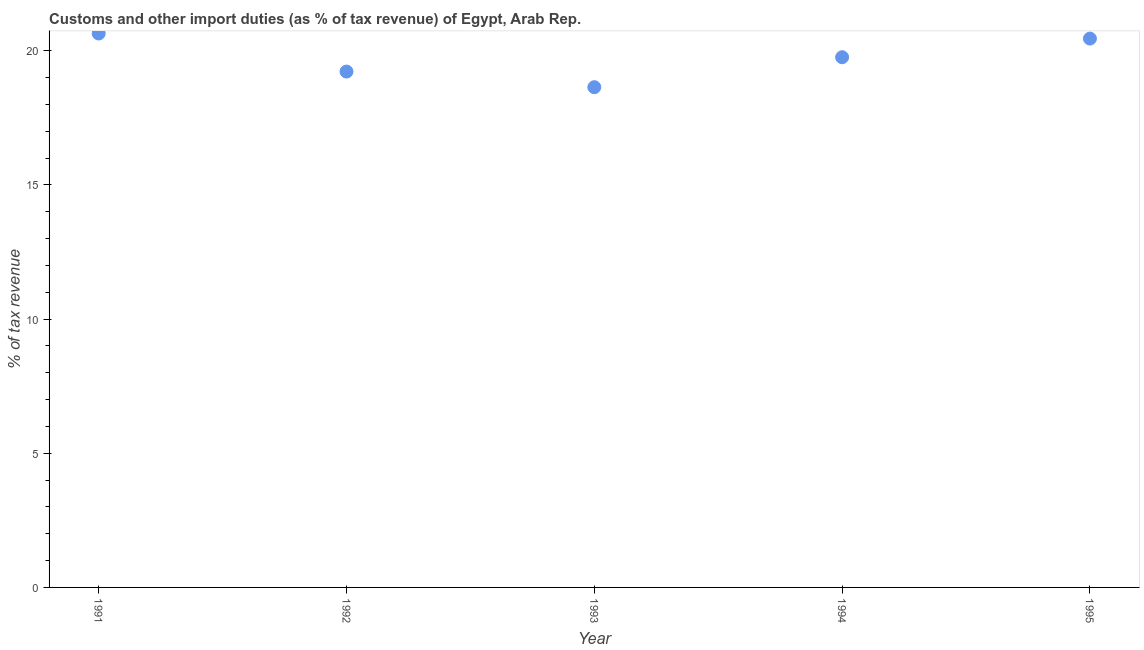What is the customs and other import duties in 1993?
Provide a short and direct response. 18.64. Across all years, what is the maximum customs and other import duties?
Your response must be concise. 20.64. Across all years, what is the minimum customs and other import duties?
Offer a terse response. 18.64. What is the sum of the customs and other import duties?
Your response must be concise. 98.7. What is the difference between the customs and other import duties in 1993 and 1994?
Keep it short and to the point. -1.12. What is the average customs and other import duties per year?
Make the answer very short. 19.74. What is the median customs and other import duties?
Your answer should be compact. 19.76. In how many years, is the customs and other import duties greater than 6 %?
Provide a succinct answer. 5. Do a majority of the years between 1992 and 1995 (inclusive) have customs and other import duties greater than 17 %?
Make the answer very short. Yes. What is the ratio of the customs and other import duties in 1991 to that in 1995?
Make the answer very short. 1.01. What is the difference between the highest and the second highest customs and other import duties?
Offer a terse response. 0.19. What is the difference between the highest and the lowest customs and other import duties?
Keep it short and to the point. 2. In how many years, is the customs and other import duties greater than the average customs and other import duties taken over all years?
Offer a very short reply. 3. How many years are there in the graph?
Make the answer very short. 5. What is the difference between two consecutive major ticks on the Y-axis?
Keep it short and to the point. 5. Are the values on the major ticks of Y-axis written in scientific E-notation?
Offer a very short reply. No. What is the title of the graph?
Your answer should be compact. Customs and other import duties (as % of tax revenue) of Egypt, Arab Rep. What is the label or title of the Y-axis?
Give a very brief answer. % of tax revenue. What is the % of tax revenue in 1991?
Offer a very short reply. 20.64. What is the % of tax revenue in 1992?
Make the answer very short. 19.22. What is the % of tax revenue in 1993?
Give a very brief answer. 18.64. What is the % of tax revenue in 1994?
Ensure brevity in your answer.  19.76. What is the % of tax revenue in 1995?
Your answer should be compact. 20.45. What is the difference between the % of tax revenue in 1991 and 1992?
Offer a very short reply. 1.42. What is the difference between the % of tax revenue in 1991 and 1993?
Make the answer very short. 2. What is the difference between the % of tax revenue in 1991 and 1994?
Ensure brevity in your answer.  0.88. What is the difference between the % of tax revenue in 1991 and 1995?
Offer a terse response. 0.19. What is the difference between the % of tax revenue in 1992 and 1993?
Offer a terse response. 0.58. What is the difference between the % of tax revenue in 1992 and 1994?
Keep it short and to the point. -0.53. What is the difference between the % of tax revenue in 1992 and 1995?
Your answer should be compact. -1.23. What is the difference between the % of tax revenue in 1993 and 1994?
Offer a terse response. -1.12. What is the difference between the % of tax revenue in 1993 and 1995?
Your answer should be very brief. -1.81. What is the difference between the % of tax revenue in 1994 and 1995?
Offer a terse response. -0.69. What is the ratio of the % of tax revenue in 1991 to that in 1992?
Keep it short and to the point. 1.07. What is the ratio of the % of tax revenue in 1991 to that in 1993?
Make the answer very short. 1.11. What is the ratio of the % of tax revenue in 1991 to that in 1994?
Your response must be concise. 1.04. What is the ratio of the % of tax revenue in 1992 to that in 1993?
Offer a terse response. 1.03. What is the ratio of the % of tax revenue in 1993 to that in 1994?
Keep it short and to the point. 0.94. What is the ratio of the % of tax revenue in 1993 to that in 1995?
Make the answer very short. 0.91. 